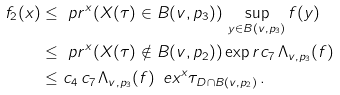Convert formula to latex. <formula><loc_0><loc_0><loc_500><loc_500>f _ { 2 } ( x ) & \leq \ p r ^ { x } ( X ( \tau ) \in B ( v , p _ { 3 } ) ) \, \sup _ { y \in B ( v , p _ { 3 } ) } f ( y ) \\ & \leq \ p r ^ { x } ( X ( \tau ) \notin B ( v , p _ { 2 } ) ) \exp r { c _ { 7 } \, \Lambda _ { v , p _ { 3 } } ( f ) } \\ & \leq c _ { 4 } \, c _ { 7 } \, \Lambda _ { v , p _ { 3 } } ( f ) \, \ e x ^ { x } \tau _ { D \cap B ( v , p _ { 2 } ) } \, .</formula> 